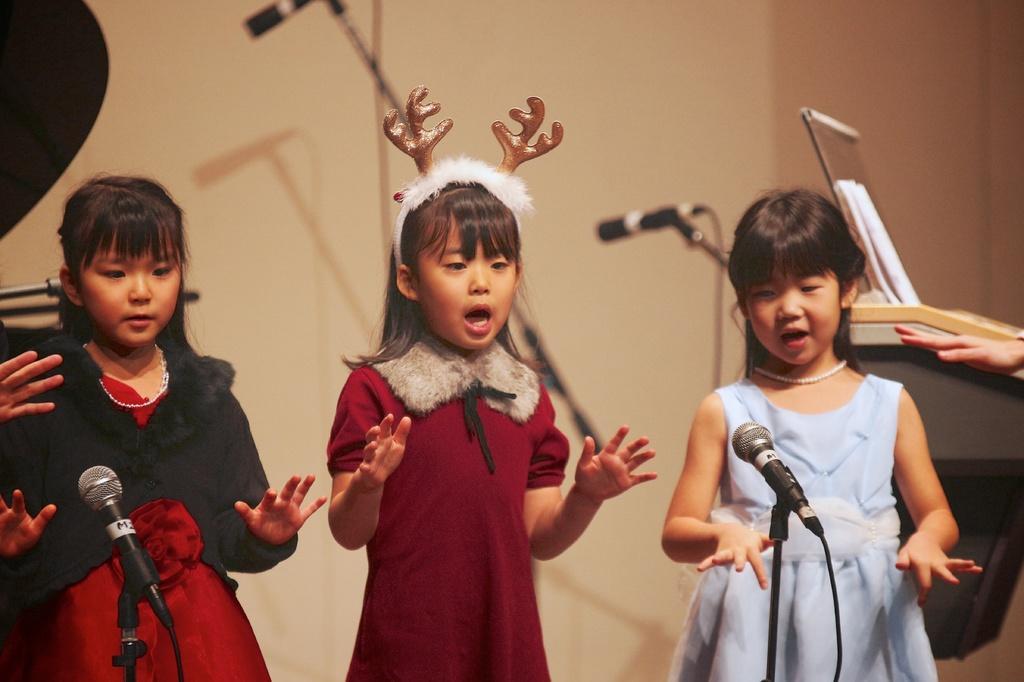Can you describe this image briefly? In this image, we can see three girls are standing and singing with actions. Here we can see few stands with microphone and wires. Right side and left side of the image, we can see human hands. Background there is a wall. Here we can see papers. 